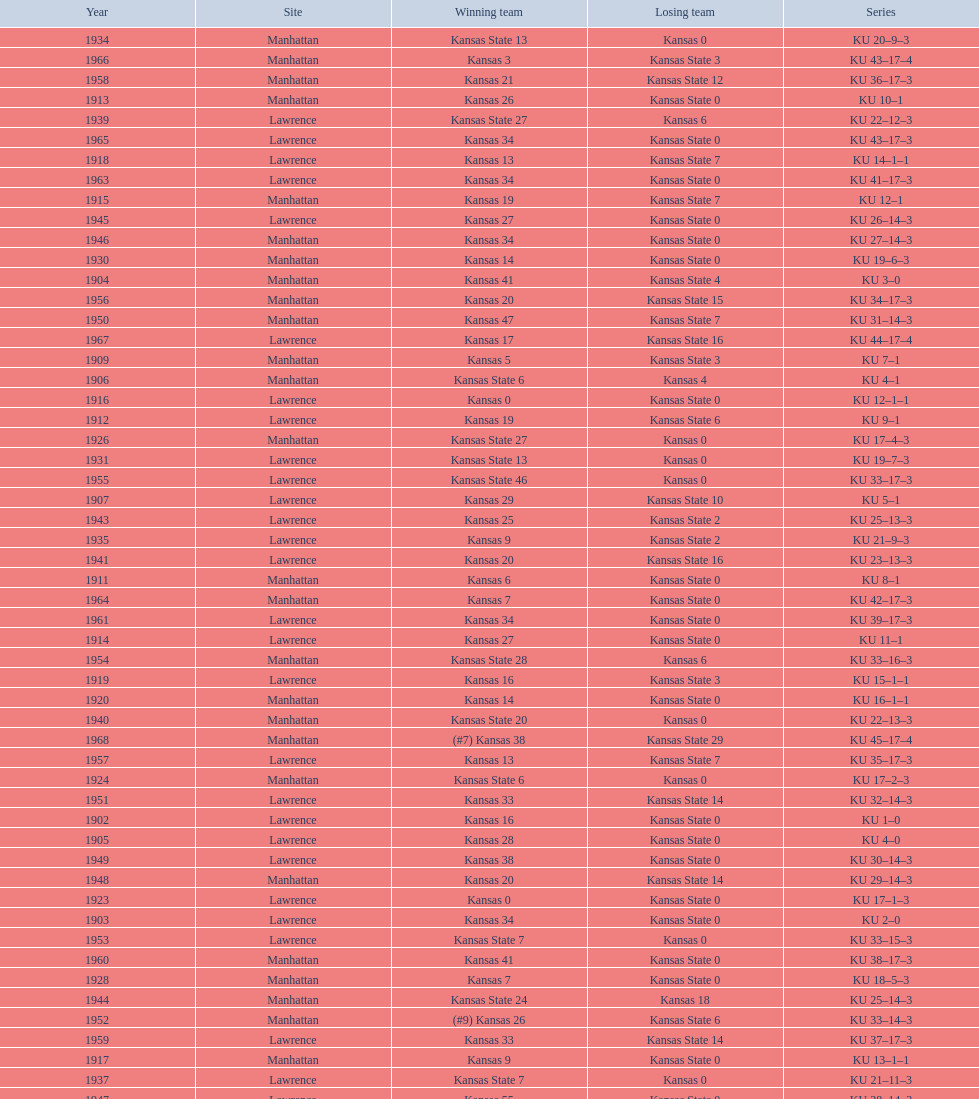What is the total number of games played? 66. 